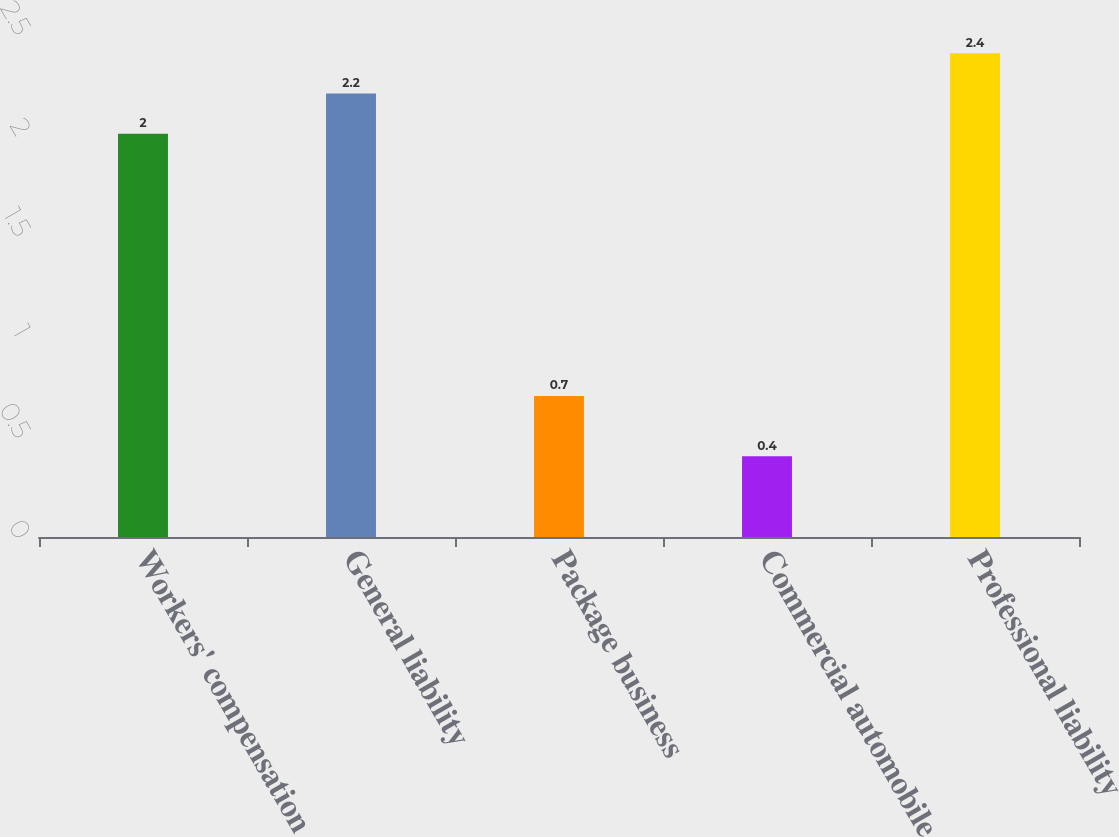<chart> <loc_0><loc_0><loc_500><loc_500><bar_chart><fcel>Workers' compensation<fcel>General liability<fcel>Package business<fcel>Commercial automobile<fcel>Professional liability<nl><fcel>2<fcel>2.2<fcel>0.7<fcel>0.4<fcel>2.4<nl></chart> 